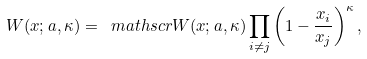Convert formula to latex. <formula><loc_0><loc_0><loc_500><loc_500>W ( x ; a , \kappa ) = \ m a t h s c r { W } ( x ; a , \kappa ) \prod _ { i \neq j } \left ( 1 - \frac { x _ { i } } { x _ { j } } \right ) ^ { \kappa } ,</formula> 